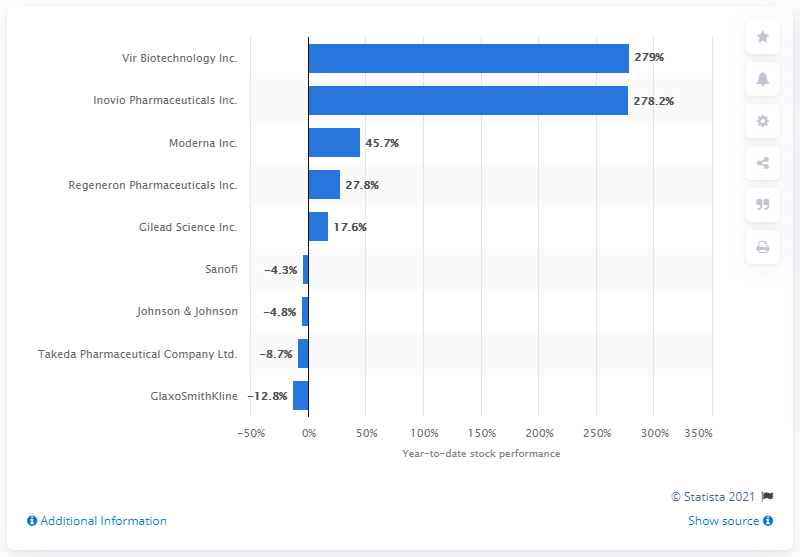Mention a couple of crucial points in this snapshot. The shares of Vir Biotechnology Inc. have increased by 279%. 